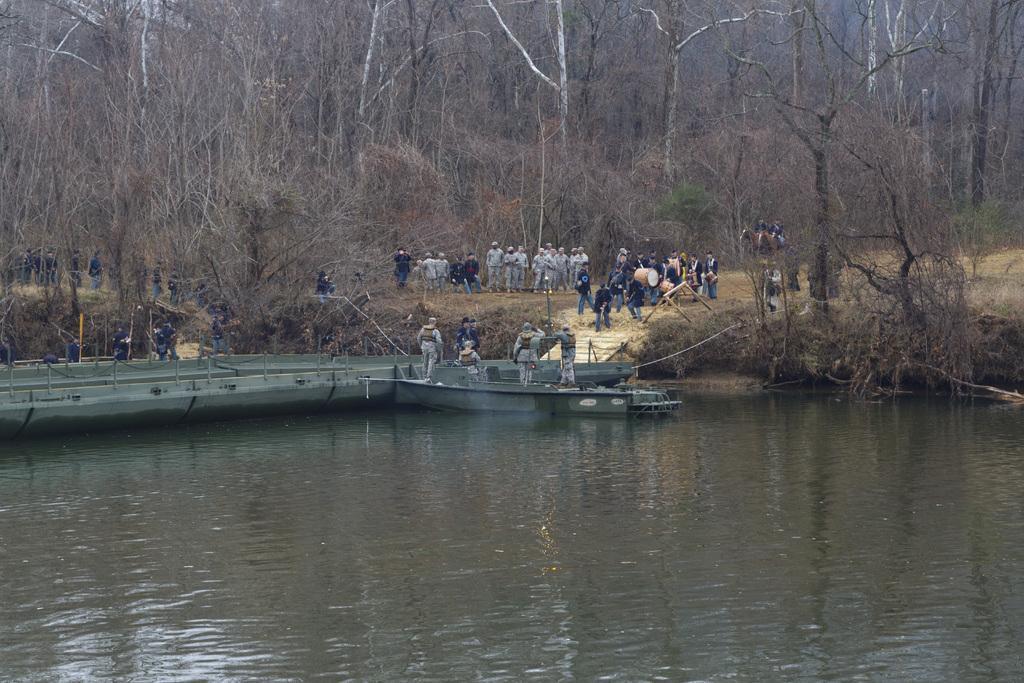Can you describe this image briefly? There is water surface in the foreground area of the image, there are few people on the boat, other are walking and trees in the background. 